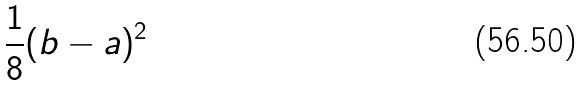Convert formula to latex. <formula><loc_0><loc_0><loc_500><loc_500>\frac { 1 } { 8 } ( b - a ) ^ { 2 }</formula> 